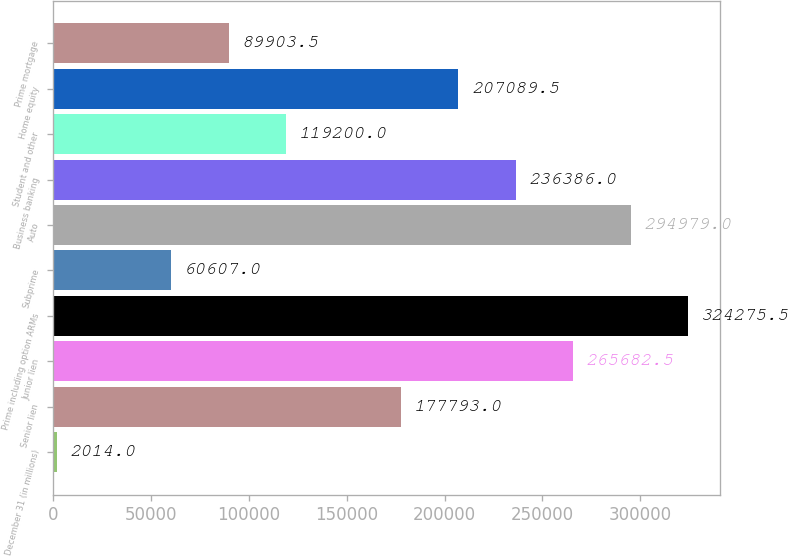Convert chart. <chart><loc_0><loc_0><loc_500><loc_500><bar_chart><fcel>December 31 (in millions)<fcel>Senior lien<fcel>Junior lien<fcel>Prime including option ARMs<fcel>Subprime<fcel>Auto<fcel>Business banking<fcel>Student and other<fcel>Home equity<fcel>Prime mortgage<nl><fcel>2014<fcel>177793<fcel>265682<fcel>324276<fcel>60607<fcel>294979<fcel>236386<fcel>119200<fcel>207090<fcel>89903.5<nl></chart> 